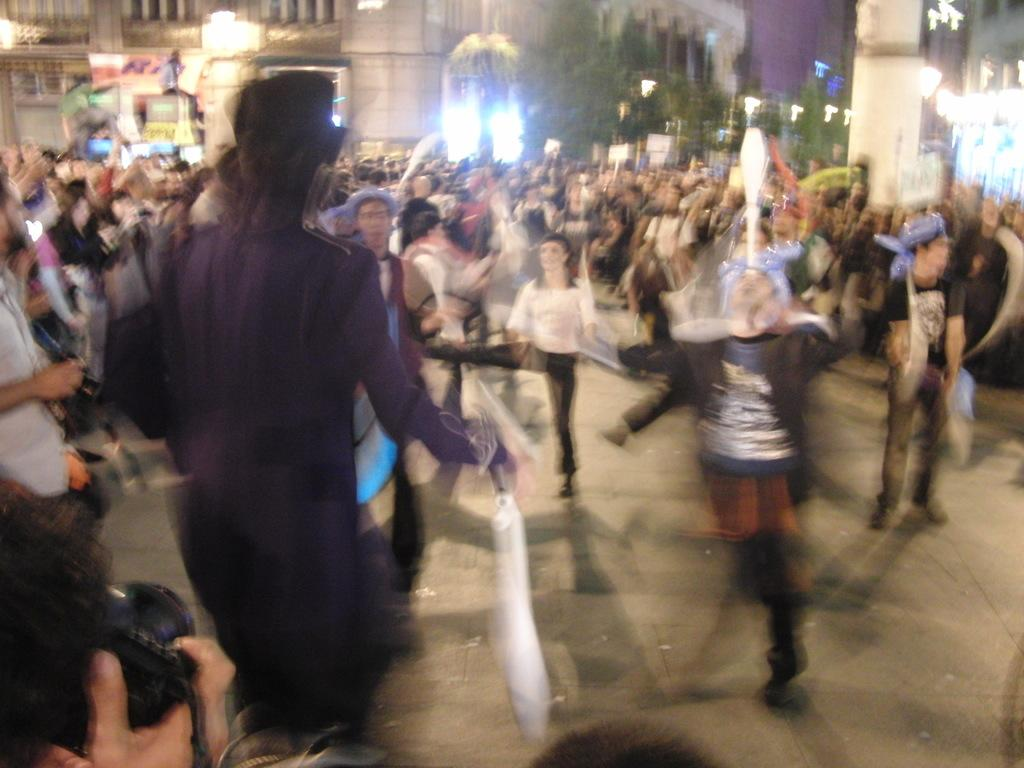What are the people in the image doing? The people in the image are standing on the road. What can be seen in the background of the image? There are buildings and trees in the background. How many loaves of bread can be seen floating in the water in the image? There are no loaves of bread or water present in the image. What type of boats are visible in the image? There are no boats present in the image. 